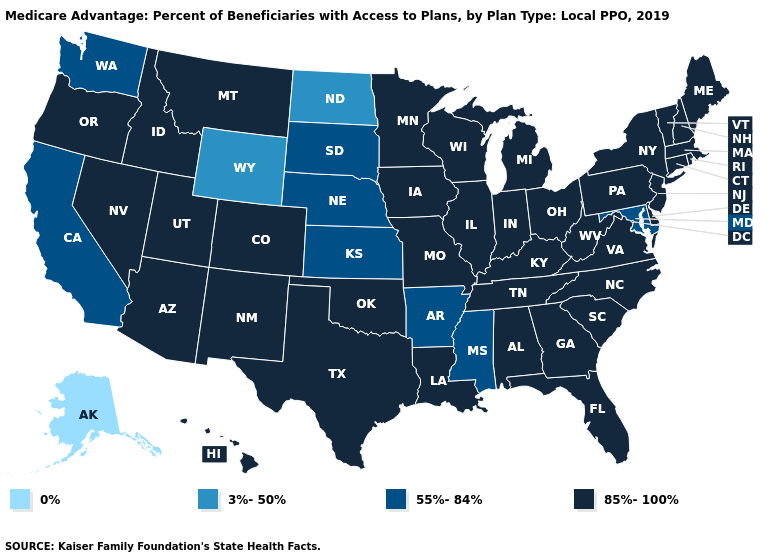How many symbols are there in the legend?
Write a very short answer. 4. Among the states that border Alabama , does Mississippi have the lowest value?
Write a very short answer. Yes. What is the value of Indiana?
Answer briefly. 85%-100%. What is the value of Vermont?
Short answer required. 85%-100%. Which states have the highest value in the USA?
Short answer required. Alabama, Arizona, Colorado, Connecticut, Delaware, Florida, Georgia, Hawaii, Idaho, Illinois, Indiana, Iowa, Kentucky, Louisiana, Maine, Massachusetts, Michigan, Minnesota, Missouri, Montana, Nevada, New Hampshire, New Jersey, New Mexico, New York, North Carolina, Ohio, Oklahoma, Oregon, Pennsylvania, Rhode Island, South Carolina, Tennessee, Texas, Utah, Vermont, Virginia, West Virginia, Wisconsin. Among the states that border Louisiana , does Texas have the lowest value?
Concise answer only. No. What is the value of Mississippi?
Quick response, please. 55%-84%. Among the states that border Iowa , does South Dakota have the highest value?
Answer briefly. No. What is the highest value in states that border Connecticut?
Write a very short answer. 85%-100%. Does the map have missing data?
Answer briefly. No. Name the states that have a value in the range 0%?
Short answer required. Alaska. Is the legend a continuous bar?
Write a very short answer. No. What is the lowest value in the USA?
Concise answer only. 0%. What is the value of Nevada?
Short answer required. 85%-100%. 